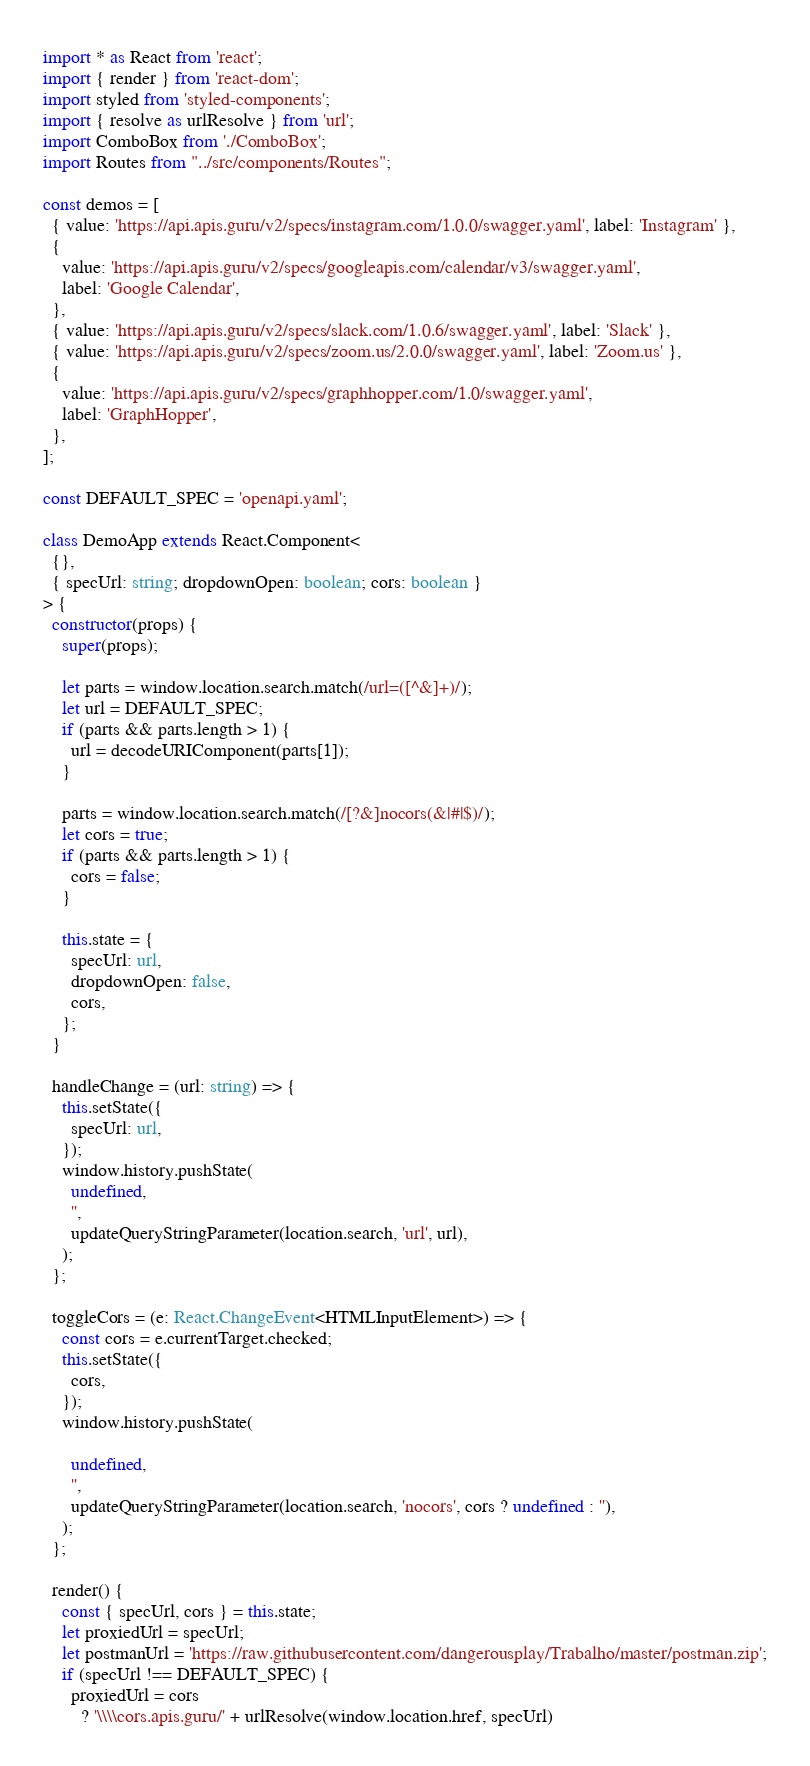Convert code to text. <code><loc_0><loc_0><loc_500><loc_500><_TypeScript_>import * as React from 'react';
import { render } from 'react-dom';
import styled from 'styled-components';
import { resolve as urlResolve } from 'url';
import ComboBox from './ComboBox';
import Routes from "../src/components/Routes";

const demos = [
  { value: 'https://api.apis.guru/v2/specs/instagram.com/1.0.0/swagger.yaml', label: 'Instagram' },
  {
    value: 'https://api.apis.guru/v2/specs/googleapis.com/calendar/v3/swagger.yaml',
    label: 'Google Calendar',
  },
  { value: 'https://api.apis.guru/v2/specs/slack.com/1.0.6/swagger.yaml', label: 'Slack' },
  { value: 'https://api.apis.guru/v2/specs/zoom.us/2.0.0/swagger.yaml', label: 'Zoom.us' },
  {
    value: 'https://api.apis.guru/v2/specs/graphhopper.com/1.0/swagger.yaml',
    label: 'GraphHopper',
  },
];

const DEFAULT_SPEC = 'openapi.yaml';

class DemoApp extends React.Component<
  {},
  { specUrl: string; dropdownOpen: boolean; cors: boolean }
> {
  constructor(props) {
    super(props);

    let parts = window.location.search.match(/url=([^&]+)/);
    let url = DEFAULT_SPEC;
    if (parts && parts.length > 1) {
      url = decodeURIComponent(parts[1]);
    }

    parts = window.location.search.match(/[?&]nocors(&|#|$)/);
    let cors = true;
    if (parts && parts.length > 1) {
      cors = false;
    }

    this.state = {
      specUrl: url,
      dropdownOpen: false,
      cors,
    };
  }

  handleChange = (url: string) => {
    this.setState({
      specUrl: url,
    });
    window.history.pushState(
      undefined,
      '',
      updateQueryStringParameter(location.search, 'url', url),
    );
  };

  toggleCors = (e: React.ChangeEvent<HTMLInputElement>) => {
    const cors = e.currentTarget.checked;
    this.setState({
      cors,
    });
    window.history.pushState(

      undefined,
      '',
      updateQueryStringParameter(location.search, 'nocors', cors ? undefined : ''),
    );
  };

  render() {
    const { specUrl, cors } = this.state;
    let proxiedUrl = specUrl;
    let postmanUrl = 'https://raw.githubusercontent.com/dangerousplay/Trabalho/master/postman.zip';
    if (specUrl !== DEFAULT_SPEC) {
      proxiedUrl = cors
        ? '\\\\cors.apis.guru/' + urlResolve(window.location.href, specUrl)</code> 